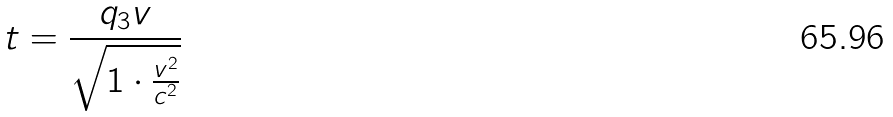Convert formula to latex. <formula><loc_0><loc_0><loc_500><loc_500>t = \frac { q _ { 3 } v } { \sqrt { 1 \cdot \frac { v ^ { 2 } } { c ^ { 2 } } } }</formula> 